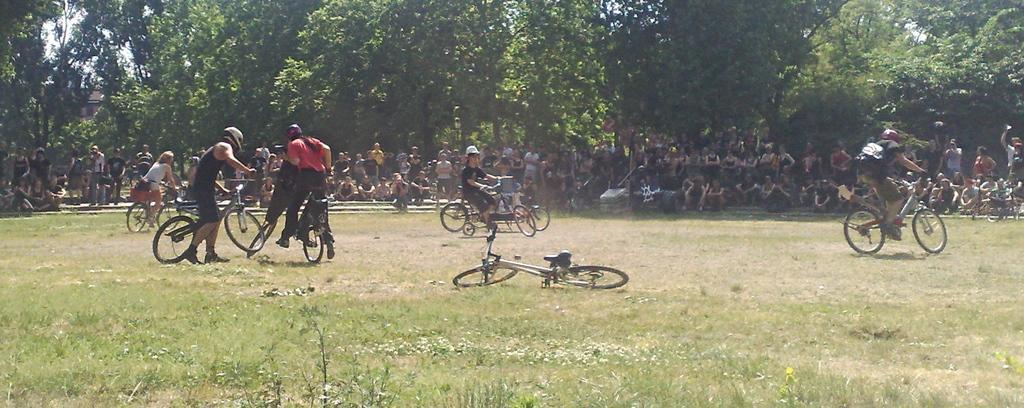Please provide a concise description of this image. In this picture I can see there are few people riding the bicycle. There is a bicycle lying on the grass. In the backdrop there are few people standing and few of them are sitting, there are few stairs in the backdrop and it looks like there is a building in the backdrop, there are few trees and the sky is clear. 